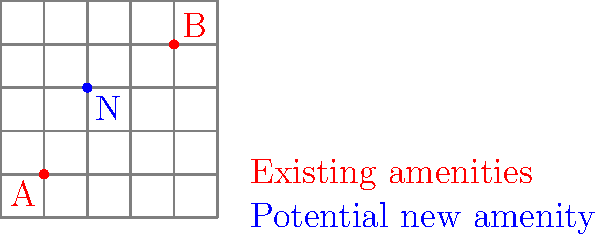In a city grid represented by a 5x5 square, two existing public amenities are located at points A(1,1) and B(4,4). The city planner is considering adding a new amenity at point N(2,3). What is the sum of the Manhattan distances from the new amenity to both existing amenities? How does this placement optimize accessibility for citizens? To solve this problem and understand the optimal placement of public amenities, let's follow these steps:

1. Recall that Manhattan distance is calculated as the sum of the absolute differences of the coordinates: $d = |x_2 - x_1| + |y_2 - y_1|$

2. Calculate the Manhattan distance from N to A:
   $d_{NA} = |2 - 1| + |3 - 1| = 1 + 2 = 3$

3. Calculate the Manhattan distance from N to B:
   $d_{NB} = |2 - 4| + |3 - 4| = 2 + 1 = 3$

4. Sum the Manhattan distances:
   $d_{total} = d_{NA} + d_{NB} = 3 + 3 = 6$

5. Optimization analysis:
   a) The new amenity N is placed equidistant from both existing amenities (3 units each).
   b) This central location minimizes the maximum distance any citizen would need to travel to reach an amenity.
   c) The total distance of 6 units represents a balance between accessibility to both existing amenities.
   d) This placement strategy ensures that no area of the city is disproportionately underserved.

6. Public space initiative perspective:
   This optimal placement aligns with the goal of creating accessible public spaces by:
   a) Reducing overall travel distances for citizens
   b) Promoting equal access to public amenities
   c) Enhancing the distribution of public services across the city grid
Answer: 6 units; centralized placement ensures equidistant accessibility and balanced coverage. 